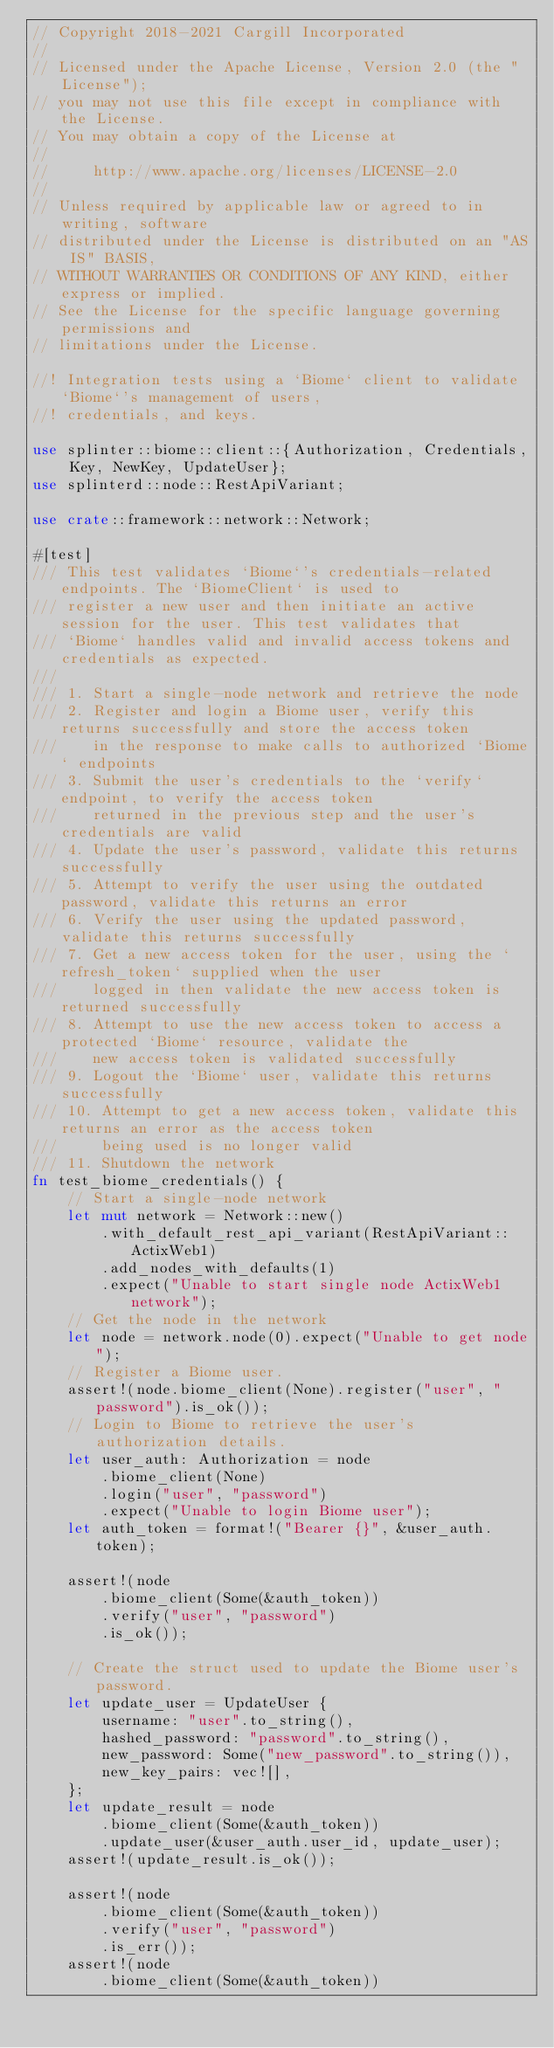<code> <loc_0><loc_0><loc_500><loc_500><_Rust_>// Copyright 2018-2021 Cargill Incorporated
//
// Licensed under the Apache License, Version 2.0 (the "License");
// you may not use this file except in compliance with the License.
// You may obtain a copy of the License at
//
//     http://www.apache.org/licenses/LICENSE-2.0
//
// Unless required by applicable law or agreed to in writing, software
// distributed under the License is distributed on an "AS IS" BASIS,
// WITHOUT WARRANTIES OR CONDITIONS OF ANY KIND, either express or implied.
// See the License for the specific language governing permissions and
// limitations under the License.

//! Integration tests using a `Biome` client to validate `Biome`'s management of users,
//! credentials, and keys.

use splinter::biome::client::{Authorization, Credentials, Key, NewKey, UpdateUser};
use splinterd::node::RestApiVariant;

use crate::framework::network::Network;

#[test]
/// This test validates `Biome`'s credentials-related endpoints. The `BiomeClient` is used to
/// register a new user and then initiate an active session for the user. This test validates that
/// `Biome` handles valid and invalid access tokens and credentials as expected.
///
/// 1. Start a single-node network and retrieve the node
/// 2. Register and login a Biome user, verify this returns successfully and store the access token
///    in the response to make calls to authorized `Biome` endpoints
/// 3. Submit the user's credentials to the `verify` endpoint, to verify the access token
///    returned in the previous step and the user's credentials are valid
/// 4. Update the user's password, validate this returns successfully
/// 5. Attempt to verify the user using the outdated password, validate this returns an error
/// 6. Verify the user using the updated password, validate this returns successfully
/// 7. Get a new access token for the user, using the `refresh_token` supplied when the user
///    logged in then validate the new access token is returned successfully
/// 8. Attempt to use the new access token to access a protected `Biome` resource, validate the
///    new access token is validated successfully
/// 9. Logout the `Biome` user, validate this returns successfully
/// 10. Attempt to get a new access token, validate this returns an error as the access token
///     being used is no longer valid
/// 11. Shutdown the network
fn test_biome_credentials() {
    // Start a single-node network
    let mut network = Network::new()
        .with_default_rest_api_variant(RestApiVariant::ActixWeb1)
        .add_nodes_with_defaults(1)
        .expect("Unable to start single node ActixWeb1 network");
    // Get the node in the network
    let node = network.node(0).expect("Unable to get node");
    // Register a Biome user.
    assert!(node.biome_client(None).register("user", "password").is_ok());
    // Login to Biome to retrieve the user's authorization details.
    let user_auth: Authorization = node
        .biome_client(None)
        .login("user", "password")
        .expect("Unable to login Biome user");
    let auth_token = format!("Bearer {}", &user_auth.token);

    assert!(node
        .biome_client(Some(&auth_token))
        .verify("user", "password")
        .is_ok());

    // Create the struct used to update the Biome user's password.
    let update_user = UpdateUser {
        username: "user".to_string(),
        hashed_password: "password".to_string(),
        new_password: Some("new_password".to_string()),
        new_key_pairs: vec![],
    };
    let update_result = node
        .biome_client(Some(&auth_token))
        .update_user(&user_auth.user_id, update_user);
    assert!(update_result.is_ok());

    assert!(node
        .biome_client(Some(&auth_token))
        .verify("user", "password")
        .is_err());
    assert!(node
        .biome_client(Some(&auth_token))</code> 